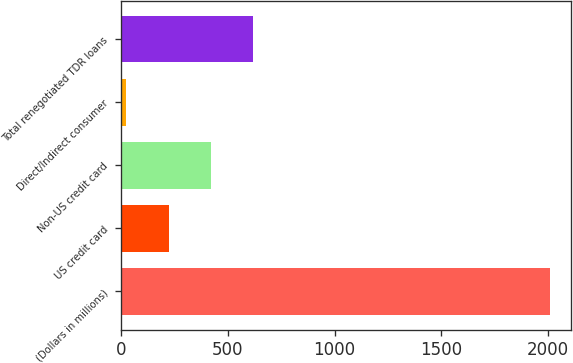Convert chart. <chart><loc_0><loc_0><loc_500><loc_500><bar_chart><fcel>(Dollars in millions)<fcel>US credit card<fcel>Non-US credit card<fcel>Direct/Indirect consumer<fcel>Total renegotiated TDR loans<nl><fcel>2011<fcel>220.9<fcel>419.8<fcel>22<fcel>618.7<nl></chart> 